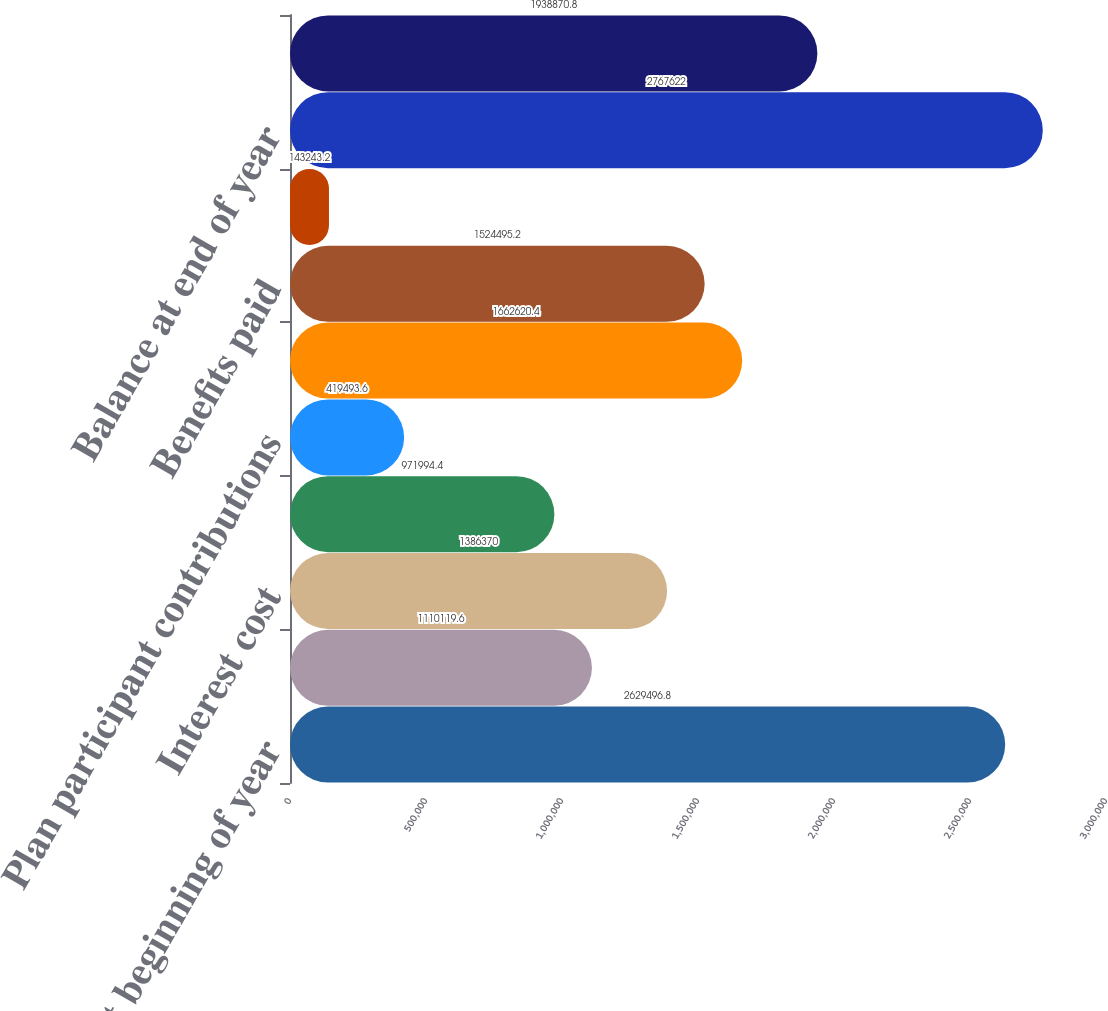<chart> <loc_0><loc_0><loc_500><loc_500><bar_chart><fcel>Balance at beginning of year<fcel>Service cost<fcel>Interest cost<fcel>Plan amendments<fcel>Plan participant contributions<fcel>Actuarial (gain)/loss<fcel>Benefits paid<fcel>Medicare Part D subsidy<fcel>Balance at end of year<fcel>Fair value of assets at<nl><fcel>2.6295e+06<fcel>1.11012e+06<fcel>1.38637e+06<fcel>971994<fcel>419494<fcel>1.66262e+06<fcel>1.5245e+06<fcel>143243<fcel>2.76762e+06<fcel>1.93887e+06<nl></chart> 